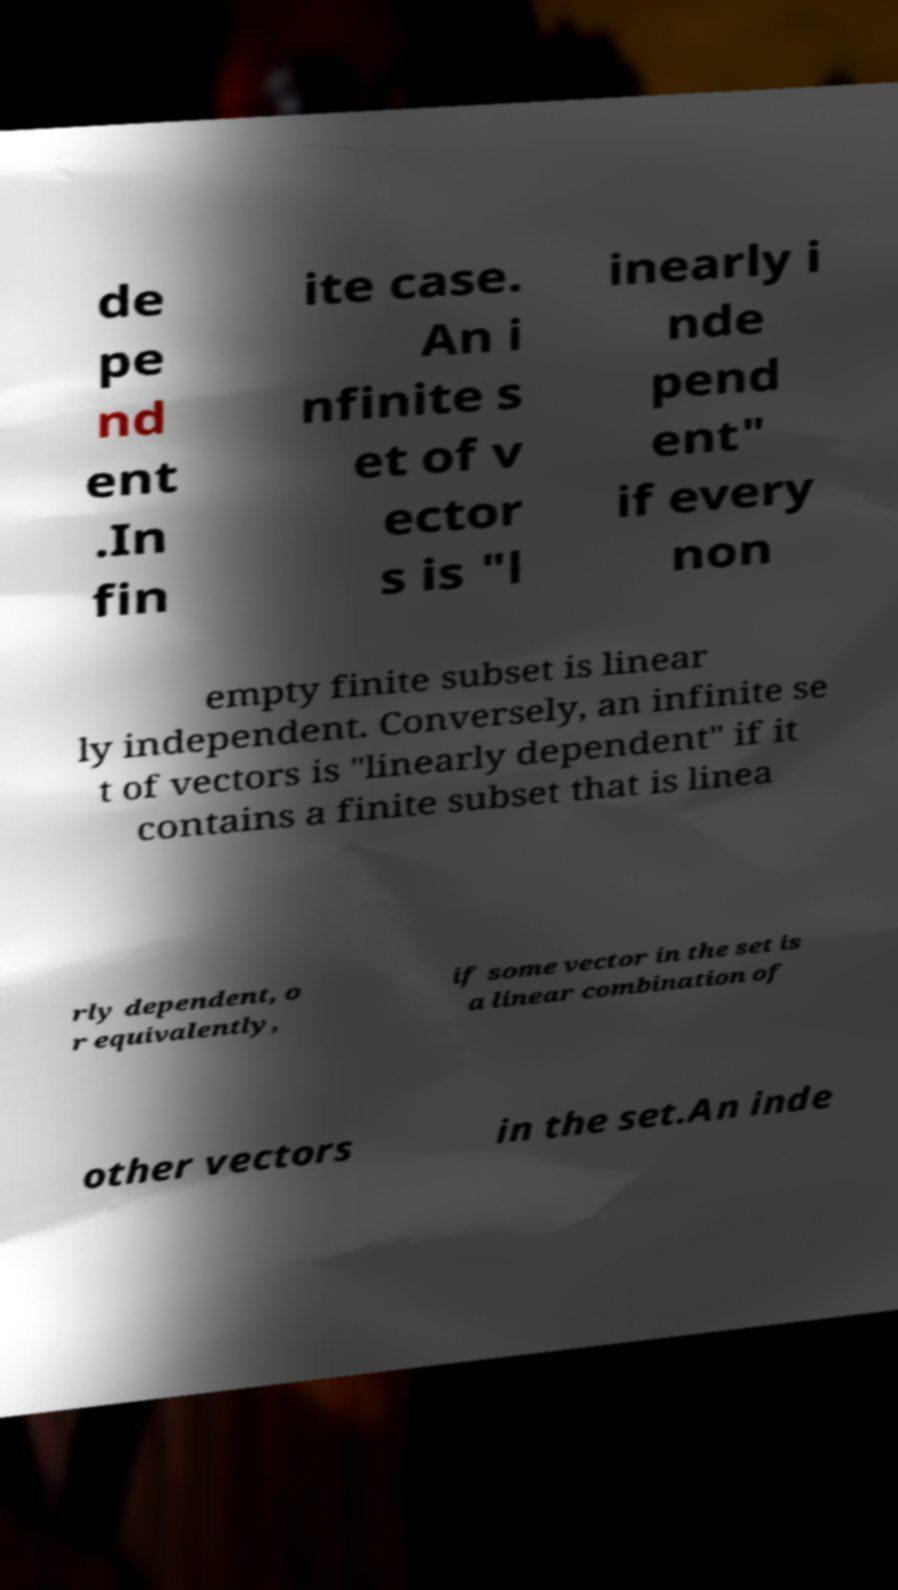I need the written content from this picture converted into text. Can you do that? de pe nd ent .In fin ite case. An i nfinite s et of v ector s is "l inearly i nde pend ent" if every non empty finite subset is linear ly independent. Conversely, an infinite se t of vectors is "linearly dependent" if it contains a finite subset that is linea rly dependent, o r equivalently, if some vector in the set is a linear combination of other vectors in the set.An inde 